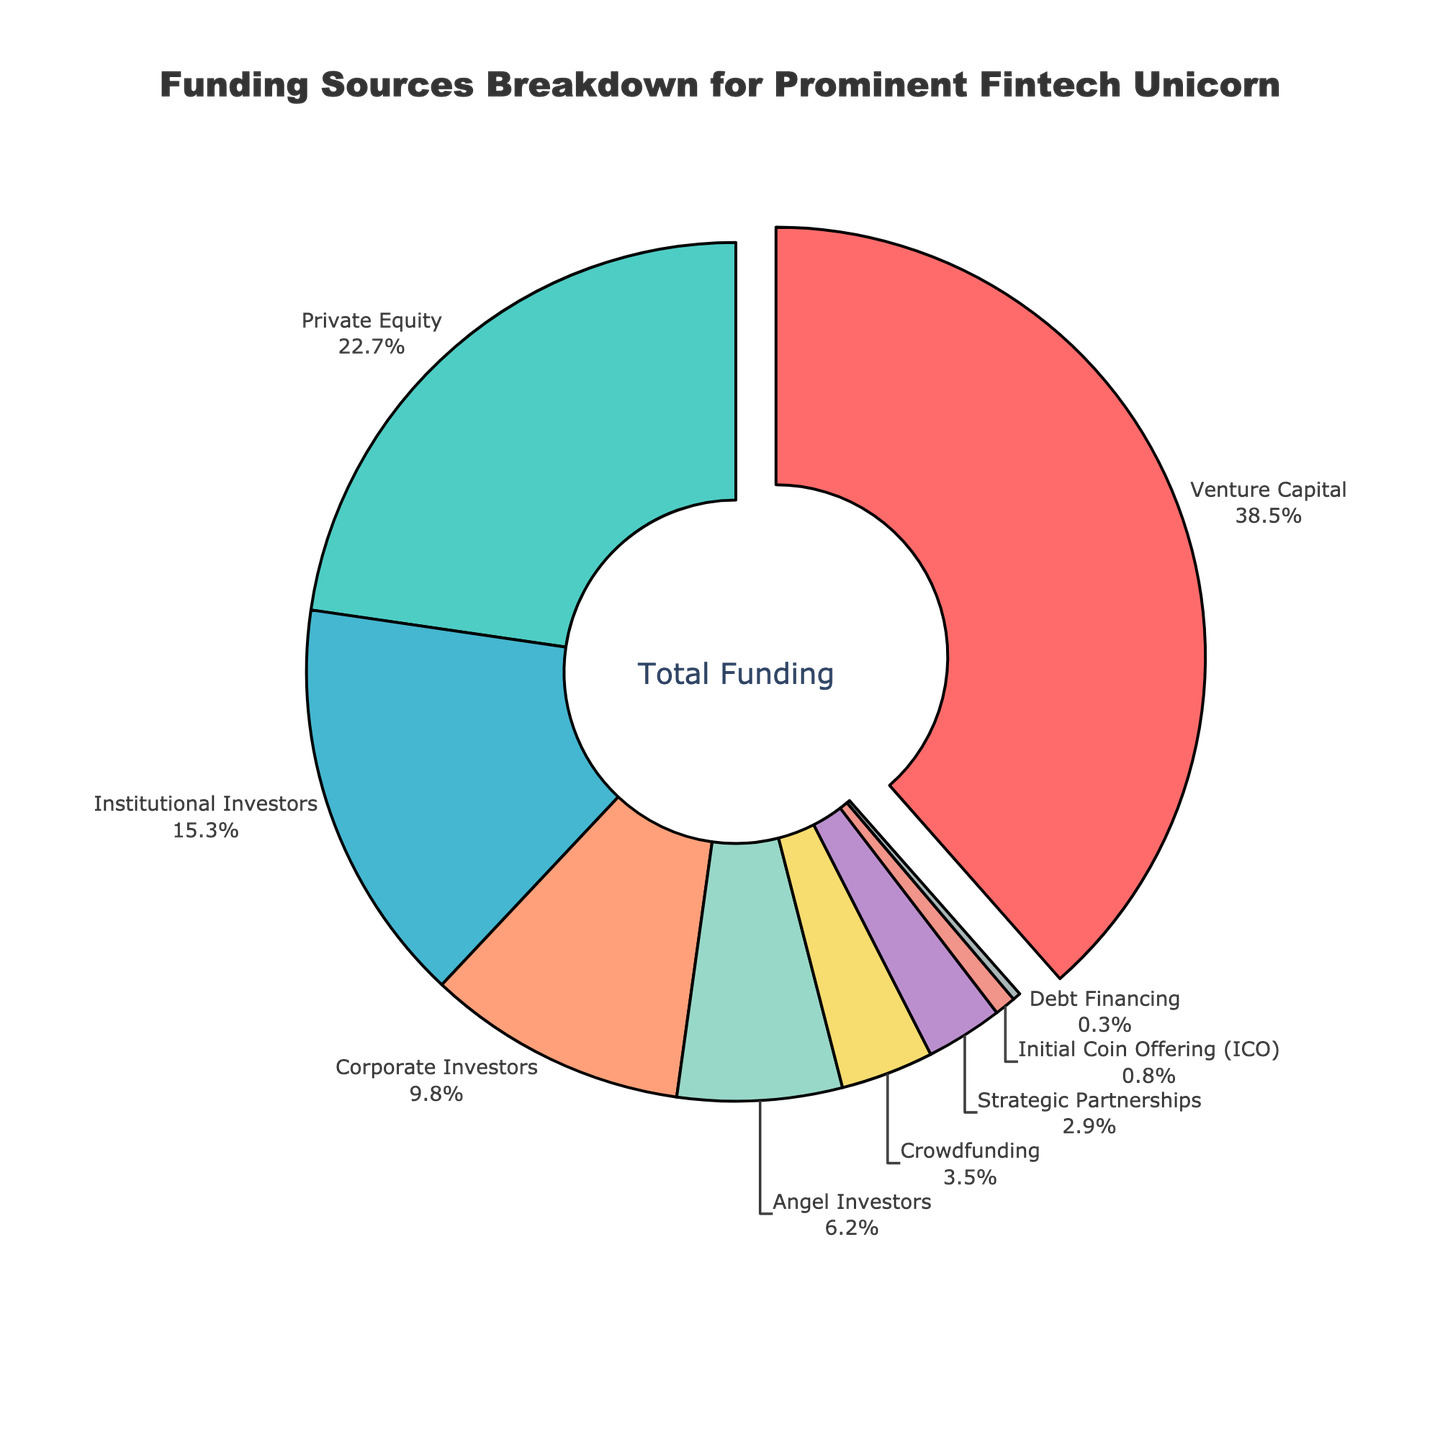Which funding source has the highest percentage? The pie chart shows the breakdown of funding sources, with the largest slice being Venture Capital.
Answer: Venture Capital What funding source contributes the least to the total funding? The pie chart clearly shows the smallest slice, which represents Debt Financing.
Answer: Debt Financing How much more funding in percentage does Venture Capital provide compared to Crowdfunding? Venture Capital provides 38.5%, and Crowdfunding provides 3.5%. The difference is 38.5% - 3.5% = 35%.
Answer: 35% Which two funding sources, when combined, make up more than 50% of the total funding? Adding the percentages of the largest two funding sources, Venture Capital (38.5%) and Private Equity (22.7%), gives us 38.5% + 22.7% = 61.2%, which is more than 50%.
Answer: Venture Capital and Private Equity Which funding sources have a percentage contribution less than 5%? The pie chart shows that Crowdfunding (3.5%), Strategic Partnerships (2.9%), Initial Coin Offering (0.8%), and Debt Financing (0.3%) each have contributions less than 5%.
Answer: Crowdfunding, Strategic Partnerships, Initial Coin Offering, Debt Financing What is the difference between the percentage contributions of Institutional Investors and Corporate Investors? Institutional Investors contribute 15.3%, and Corporate Investors contribute 9.8%. The difference is 15.3% - 9.8% = 5.5%.
Answer: 5.5% What is the total percentage of funding contributed by Angel Investors, Crowdfunding, and Strategic Partnerships combined? Summing the percentages for Angel Investors (6.2%), Crowdfunding (3.5%), and Strategic Partnerships (2.9%) gives 6.2% + 3.5% + 2.9% = 12.6%.
Answer: 12.6% Compare the total contributions of Corporate Investors and Private Equity. Which is greater and by how much? Private Equity contributes 22.7%, while Corporate Investors contribute 9.8%. The difference is 22.7% - 9.8% = 12.9%. Private Equity contributes more.
Answer: Private Equity by 12.9% If we consider Institutional Investors and Corporate Investors together, would their combined contribution surpass Venture Capital? Institutional Investors contribute 15.3%, and Corporate Investors contribute 9.8%. Combined, they contribute 15.3% + 9.8% = 25.1%, which is less than Venture Capital's 38.5%.
Answer: No What is the combined contribution percentage of the three smallest funding sources? The three smallest funding sources are Initial Coin Offering (0.8%), Debt Financing (0.3%), and Strategic Partnerships (2.9%). Their combined contribution is 0.8% + 0.3% + 2.9% = 4%.
Answer: 4% 